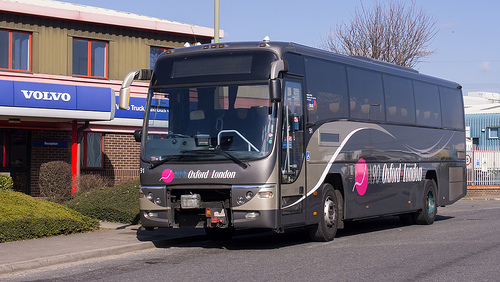Please provide a short description for this region: [0.72, 0.68, 0.81, 0.76]. The lower part of the image shows a stretch of bland gray street that seems empty, bordered by the curb and lacking vibrant activities. 